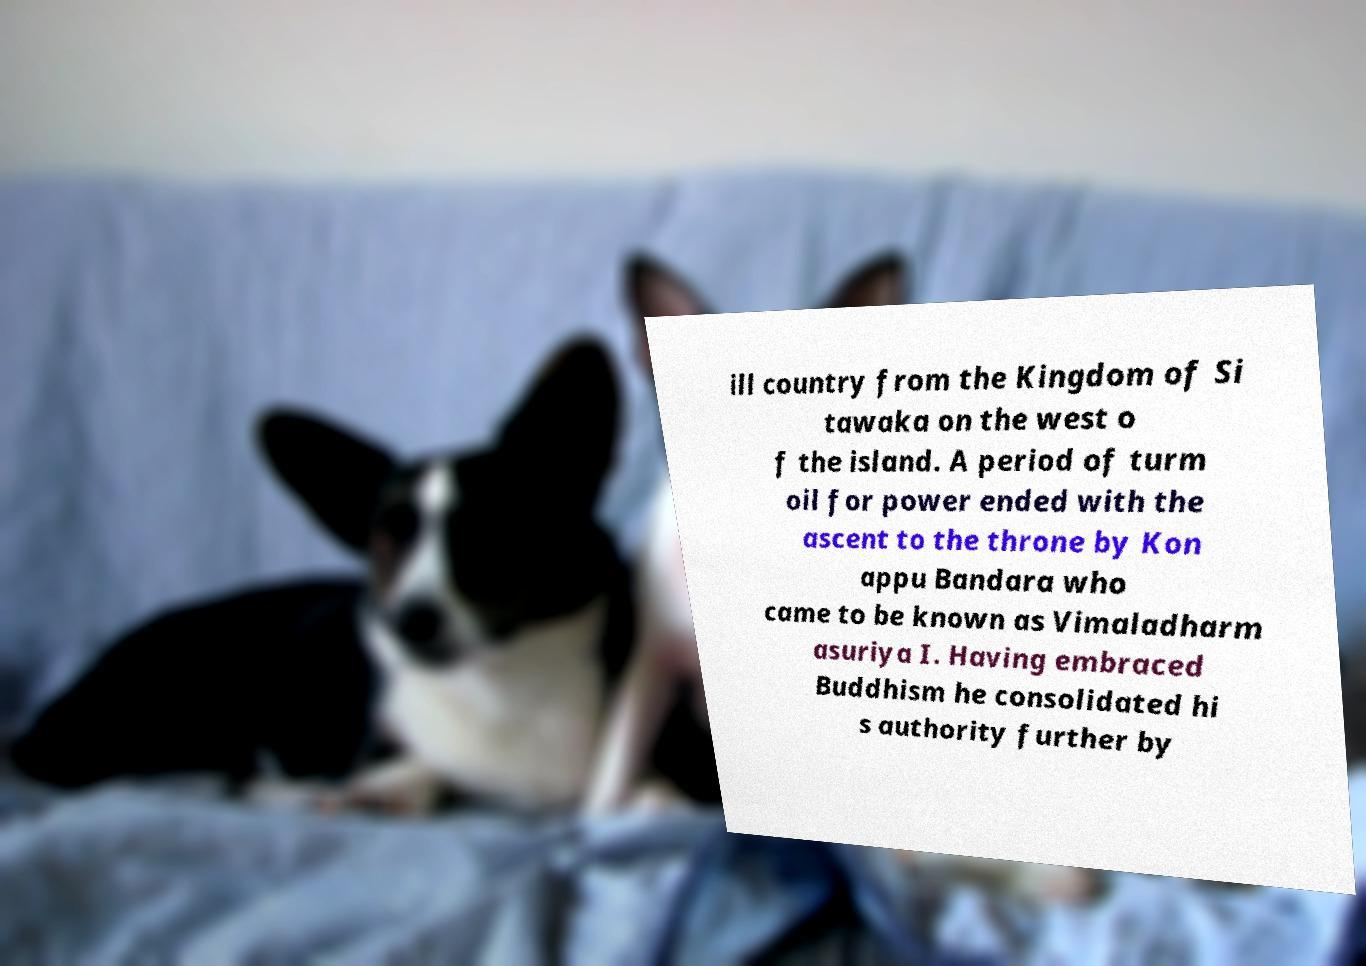Can you accurately transcribe the text from the provided image for me? ill country from the Kingdom of Si tawaka on the west o f the island. A period of turm oil for power ended with the ascent to the throne by Kon appu Bandara who came to be known as Vimaladharm asuriya I. Having embraced Buddhism he consolidated hi s authority further by 